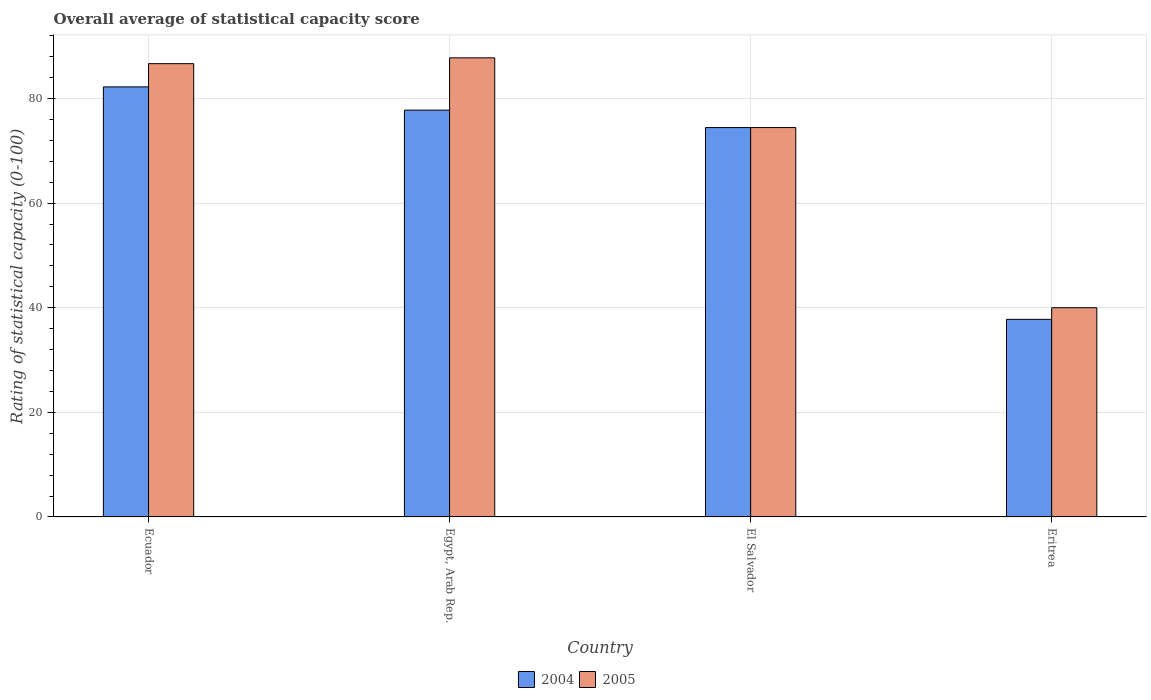How many different coloured bars are there?
Offer a terse response. 2. Are the number of bars per tick equal to the number of legend labels?
Ensure brevity in your answer.  Yes. How many bars are there on the 1st tick from the left?
Your response must be concise. 2. How many bars are there on the 4th tick from the right?
Keep it short and to the point. 2. What is the label of the 1st group of bars from the left?
Ensure brevity in your answer.  Ecuador. In how many cases, is the number of bars for a given country not equal to the number of legend labels?
Your answer should be very brief. 0. What is the rating of statistical capacity in 2005 in El Salvador?
Offer a very short reply. 74.44. Across all countries, what is the maximum rating of statistical capacity in 2005?
Your answer should be very brief. 87.78. Across all countries, what is the minimum rating of statistical capacity in 2005?
Make the answer very short. 40. In which country was the rating of statistical capacity in 2005 maximum?
Your answer should be very brief. Egypt, Arab Rep. In which country was the rating of statistical capacity in 2004 minimum?
Your response must be concise. Eritrea. What is the total rating of statistical capacity in 2005 in the graph?
Offer a very short reply. 288.89. What is the difference between the rating of statistical capacity in 2004 in Ecuador and that in El Salvador?
Provide a succinct answer. 7.78. What is the difference between the rating of statistical capacity in 2004 in Ecuador and the rating of statistical capacity in 2005 in Egypt, Arab Rep.?
Your answer should be compact. -5.56. What is the average rating of statistical capacity in 2004 per country?
Offer a terse response. 68.06. What is the difference between the rating of statistical capacity of/in 2005 and rating of statistical capacity of/in 2004 in Ecuador?
Provide a succinct answer. 4.44. What is the ratio of the rating of statistical capacity in 2005 in El Salvador to that in Eritrea?
Provide a succinct answer. 1.86. What is the difference between the highest and the second highest rating of statistical capacity in 2004?
Provide a succinct answer. -7.78. What is the difference between the highest and the lowest rating of statistical capacity in 2004?
Make the answer very short. 44.44. Is the sum of the rating of statistical capacity in 2005 in Ecuador and El Salvador greater than the maximum rating of statistical capacity in 2004 across all countries?
Your response must be concise. Yes. What does the 2nd bar from the left in El Salvador represents?
Provide a short and direct response. 2005. How many countries are there in the graph?
Your response must be concise. 4. What is the difference between two consecutive major ticks on the Y-axis?
Your response must be concise. 20. Does the graph contain grids?
Offer a terse response. Yes. How many legend labels are there?
Offer a terse response. 2. What is the title of the graph?
Your response must be concise. Overall average of statistical capacity score. What is the label or title of the X-axis?
Give a very brief answer. Country. What is the label or title of the Y-axis?
Offer a terse response. Rating of statistical capacity (0-100). What is the Rating of statistical capacity (0-100) of 2004 in Ecuador?
Your answer should be compact. 82.22. What is the Rating of statistical capacity (0-100) of 2005 in Ecuador?
Make the answer very short. 86.67. What is the Rating of statistical capacity (0-100) in 2004 in Egypt, Arab Rep.?
Give a very brief answer. 77.78. What is the Rating of statistical capacity (0-100) of 2005 in Egypt, Arab Rep.?
Provide a short and direct response. 87.78. What is the Rating of statistical capacity (0-100) in 2004 in El Salvador?
Provide a succinct answer. 74.44. What is the Rating of statistical capacity (0-100) of 2005 in El Salvador?
Your answer should be very brief. 74.44. What is the Rating of statistical capacity (0-100) in 2004 in Eritrea?
Your response must be concise. 37.78. What is the Rating of statistical capacity (0-100) in 2005 in Eritrea?
Provide a succinct answer. 40. Across all countries, what is the maximum Rating of statistical capacity (0-100) of 2004?
Your answer should be compact. 82.22. Across all countries, what is the maximum Rating of statistical capacity (0-100) in 2005?
Provide a succinct answer. 87.78. Across all countries, what is the minimum Rating of statistical capacity (0-100) of 2004?
Keep it short and to the point. 37.78. What is the total Rating of statistical capacity (0-100) in 2004 in the graph?
Your response must be concise. 272.22. What is the total Rating of statistical capacity (0-100) in 2005 in the graph?
Offer a very short reply. 288.89. What is the difference between the Rating of statistical capacity (0-100) in 2004 in Ecuador and that in Egypt, Arab Rep.?
Give a very brief answer. 4.44. What is the difference between the Rating of statistical capacity (0-100) in 2005 in Ecuador and that in Egypt, Arab Rep.?
Your response must be concise. -1.11. What is the difference between the Rating of statistical capacity (0-100) of 2004 in Ecuador and that in El Salvador?
Keep it short and to the point. 7.78. What is the difference between the Rating of statistical capacity (0-100) in 2005 in Ecuador and that in El Salvador?
Offer a very short reply. 12.22. What is the difference between the Rating of statistical capacity (0-100) of 2004 in Ecuador and that in Eritrea?
Give a very brief answer. 44.44. What is the difference between the Rating of statistical capacity (0-100) in 2005 in Ecuador and that in Eritrea?
Ensure brevity in your answer.  46.67. What is the difference between the Rating of statistical capacity (0-100) in 2005 in Egypt, Arab Rep. and that in El Salvador?
Give a very brief answer. 13.33. What is the difference between the Rating of statistical capacity (0-100) in 2005 in Egypt, Arab Rep. and that in Eritrea?
Offer a terse response. 47.78. What is the difference between the Rating of statistical capacity (0-100) in 2004 in El Salvador and that in Eritrea?
Offer a terse response. 36.67. What is the difference between the Rating of statistical capacity (0-100) in 2005 in El Salvador and that in Eritrea?
Your answer should be very brief. 34.44. What is the difference between the Rating of statistical capacity (0-100) of 2004 in Ecuador and the Rating of statistical capacity (0-100) of 2005 in Egypt, Arab Rep.?
Give a very brief answer. -5.56. What is the difference between the Rating of statistical capacity (0-100) in 2004 in Ecuador and the Rating of statistical capacity (0-100) in 2005 in El Salvador?
Make the answer very short. 7.78. What is the difference between the Rating of statistical capacity (0-100) in 2004 in Ecuador and the Rating of statistical capacity (0-100) in 2005 in Eritrea?
Your response must be concise. 42.22. What is the difference between the Rating of statistical capacity (0-100) in 2004 in Egypt, Arab Rep. and the Rating of statistical capacity (0-100) in 2005 in Eritrea?
Provide a succinct answer. 37.78. What is the difference between the Rating of statistical capacity (0-100) of 2004 in El Salvador and the Rating of statistical capacity (0-100) of 2005 in Eritrea?
Ensure brevity in your answer.  34.44. What is the average Rating of statistical capacity (0-100) in 2004 per country?
Ensure brevity in your answer.  68.06. What is the average Rating of statistical capacity (0-100) of 2005 per country?
Your answer should be very brief. 72.22. What is the difference between the Rating of statistical capacity (0-100) in 2004 and Rating of statistical capacity (0-100) in 2005 in Ecuador?
Your answer should be very brief. -4.44. What is the difference between the Rating of statistical capacity (0-100) in 2004 and Rating of statistical capacity (0-100) in 2005 in Eritrea?
Your answer should be compact. -2.22. What is the ratio of the Rating of statistical capacity (0-100) of 2004 in Ecuador to that in Egypt, Arab Rep.?
Your answer should be compact. 1.06. What is the ratio of the Rating of statistical capacity (0-100) in 2005 in Ecuador to that in Egypt, Arab Rep.?
Give a very brief answer. 0.99. What is the ratio of the Rating of statistical capacity (0-100) in 2004 in Ecuador to that in El Salvador?
Offer a very short reply. 1.1. What is the ratio of the Rating of statistical capacity (0-100) of 2005 in Ecuador to that in El Salvador?
Provide a succinct answer. 1.16. What is the ratio of the Rating of statistical capacity (0-100) in 2004 in Ecuador to that in Eritrea?
Your answer should be compact. 2.18. What is the ratio of the Rating of statistical capacity (0-100) in 2005 in Ecuador to that in Eritrea?
Provide a succinct answer. 2.17. What is the ratio of the Rating of statistical capacity (0-100) in 2004 in Egypt, Arab Rep. to that in El Salvador?
Provide a succinct answer. 1.04. What is the ratio of the Rating of statistical capacity (0-100) in 2005 in Egypt, Arab Rep. to that in El Salvador?
Offer a very short reply. 1.18. What is the ratio of the Rating of statistical capacity (0-100) in 2004 in Egypt, Arab Rep. to that in Eritrea?
Your response must be concise. 2.06. What is the ratio of the Rating of statistical capacity (0-100) in 2005 in Egypt, Arab Rep. to that in Eritrea?
Provide a short and direct response. 2.19. What is the ratio of the Rating of statistical capacity (0-100) in 2004 in El Salvador to that in Eritrea?
Your answer should be very brief. 1.97. What is the ratio of the Rating of statistical capacity (0-100) of 2005 in El Salvador to that in Eritrea?
Ensure brevity in your answer.  1.86. What is the difference between the highest and the second highest Rating of statistical capacity (0-100) of 2004?
Your answer should be compact. 4.44. What is the difference between the highest and the second highest Rating of statistical capacity (0-100) in 2005?
Offer a terse response. 1.11. What is the difference between the highest and the lowest Rating of statistical capacity (0-100) in 2004?
Give a very brief answer. 44.44. What is the difference between the highest and the lowest Rating of statistical capacity (0-100) in 2005?
Your response must be concise. 47.78. 